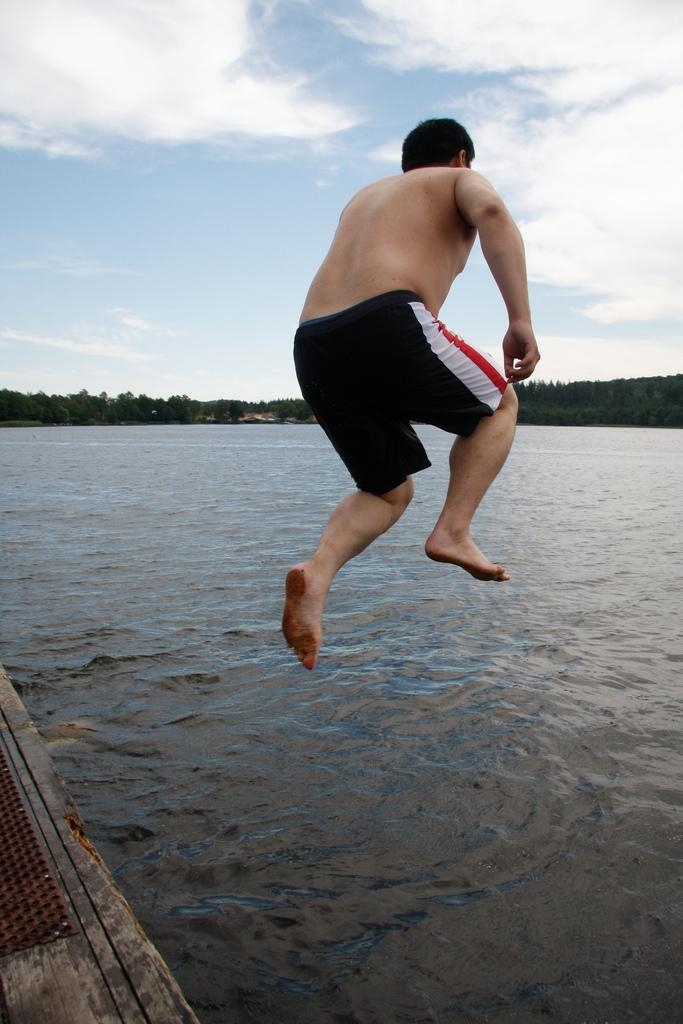What is the main subject of the image? There is a man in the image. What is the man doing in the image? The man is jumping. What can be seen in the background of the image? There are trees in the background of the image. What is visible at the top of the image? The sky is visible at the top of the image. What type of surface is visible in the bottom left of the image? There is a wooden surface in the bottom left of the image. What type of caption is written on the jail cell in the image? There is no jail or caption present in the image; it features a man jumping near water with trees and a wooden surface in the background. 